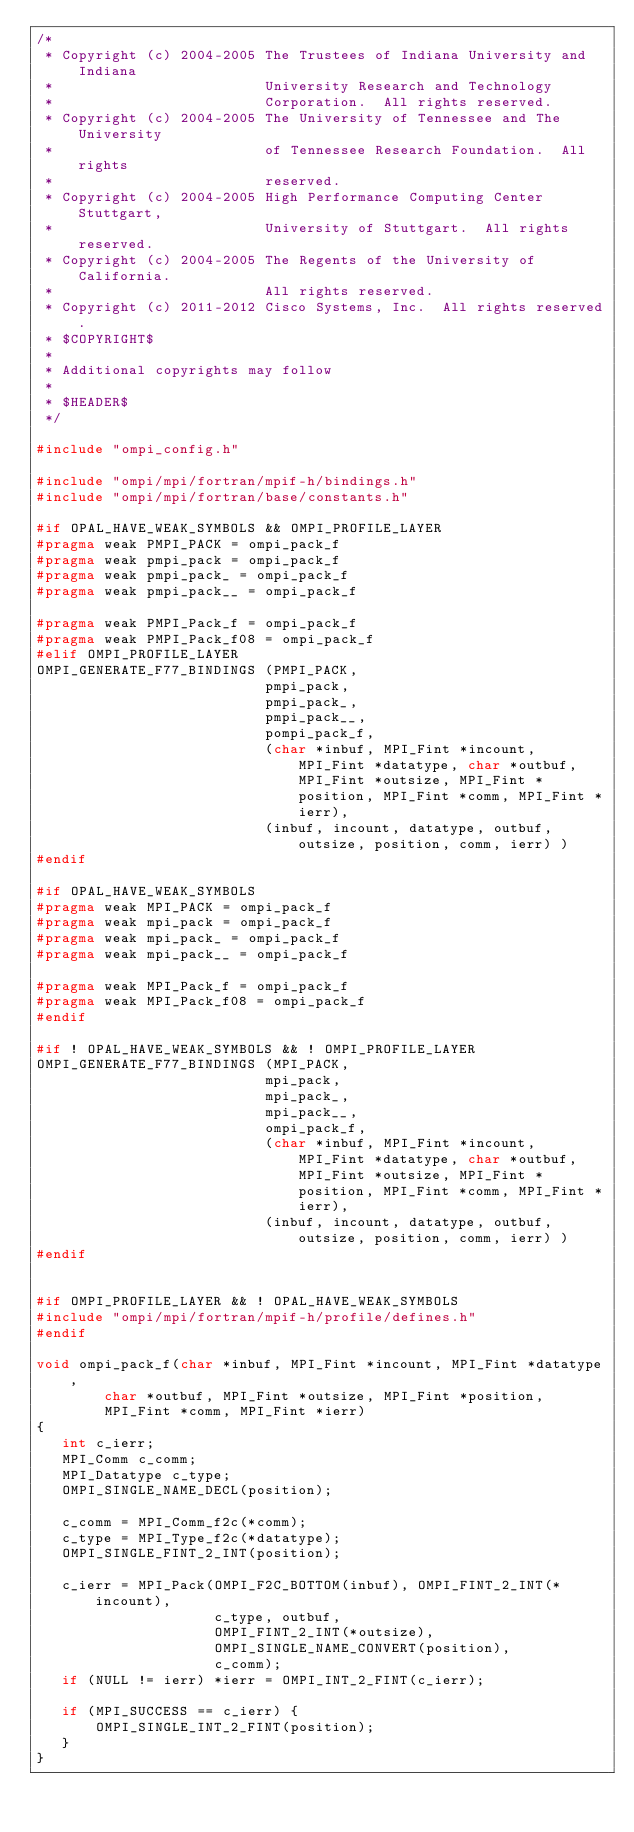Convert code to text. <code><loc_0><loc_0><loc_500><loc_500><_C_>/*
 * Copyright (c) 2004-2005 The Trustees of Indiana University and Indiana
 *                         University Research and Technology
 *                         Corporation.  All rights reserved.
 * Copyright (c) 2004-2005 The University of Tennessee and The University
 *                         of Tennessee Research Foundation.  All rights
 *                         reserved.
 * Copyright (c) 2004-2005 High Performance Computing Center Stuttgart, 
 *                         University of Stuttgart.  All rights reserved.
 * Copyright (c) 2004-2005 The Regents of the University of California.
 *                         All rights reserved.
 * Copyright (c) 2011-2012 Cisco Systems, Inc.  All rights reserved.
 * $COPYRIGHT$
 * 
 * Additional copyrights may follow
 * 
 * $HEADER$
 */

#include "ompi_config.h"

#include "ompi/mpi/fortran/mpif-h/bindings.h"
#include "ompi/mpi/fortran/base/constants.h"

#if OPAL_HAVE_WEAK_SYMBOLS && OMPI_PROFILE_LAYER
#pragma weak PMPI_PACK = ompi_pack_f
#pragma weak pmpi_pack = ompi_pack_f
#pragma weak pmpi_pack_ = ompi_pack_f
#pragma weak pmpi_pack__ = ompi_pack_f

#pragma weak PMPI_Pack_f = ompi_pack_f
#pragma weak PMPI_Pack_f08 = ompi_pack_f
#elif OMPI_PROFILE_LAYER
OMPI_GENERATE_F77_BINDINGS (PMPI_PACK,
                           pmpi_pack,
                           pmpi_pack_,
                           pmpi_pack__,
                           pompi_pack_f,
                           (char *inbuf, MPI_Fint *incount, MPI_Fint *datatype, char *outbuf, MPI_Fint *outsize, MPI_Fint *position, MPI_Fint *comm, MPI_Fint *ierr),
                           (inbuf, incount, datatype, outbuf, outsize, position, comm, ierr) )
#endif

#if OPAL_HAVE_WEAK_SYMBOLS
#pragma weak MPI_PACK = ompi_pack_f
#pragma weak mpi_pack = ompi_pack_f
#pragma weak mpi_pack_ = ompi_pack_f
#pragma weak mpi_pack__ = ompi_pack_f

#pragma weak MPI_Pack_f = ompi_pack_f
#pragma weak MPI_Pack_f08 = ompi_pack_f
#endif

#if ! OPAL_HAVE_WEAK_SYMBOLS && ! OMPI_PROFILE_LAYER
OMPI_GENERATE_F77_BINDINGS (MPI_PACK,
                           mpi_pack,
                           mpi_pack_,
                           mpi_pack__,
                           ompi_pack_f,
                           (char *inbuf, MPI_Fint *incount, MPI_Fint *datatype, char *outbuf, MPI_Fint *outsize, MPI_Fint *position, MPI_Fint *comm, MPI_Fint *ierr),
                           (inbuf, incount, datatype, outbuf, outsize, position, comm, ierr) )
#endif


#if OMPI_PROFILE_LAYER && ! OPAL_HAVE_WEAK_SYMBOLS
#include "ompi/mpi/fortran/mpif-h/profile/defines.h"
#endif

void ompi_pack_f(char *inbuf, MPI_Fint *incount, MPI_Fint *datatype,
		char *outbuf, MPI_Fint *outsize, MPI_Fint *position, 
		MPI_Fint *comm, MPI_Fint *ierr)
{
   int c_ierr;
   MPI_Comm c_comm;
   MPI_Datatype c_type;
   OMPI_SINGLE_NAME_DECL(position);

   c_comm = MPI_Comm_f2c(*comm);
   c_type = MPI_Type_f2c(*datatype);
   OMPI_SINGLE_FINT_2_INT(position);
   
   c_ierr = MPI_Pack(OMPI_F2C_BOTTOM(inbuf), OMPI_FINT_2_INT(*incount),
                     c_type, outbuf,
                     OMPI_FINT_2_INT(*outsize),
                     OMPI_SINGLE_NAME_CONVERT(position),
                     c_comm);
   if (NULL != ierr) *ierr = OMPI_INT_2_FINT(c_ierr);
				     
   if (MPI_SUCCESS == c_ierr) {
       OMPI_SINGLE_INT_2_FINT(position);			     
   }
}
</code> 